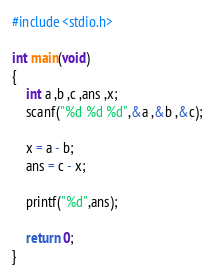<code> <loc_0><loc_0><loc_500><loc_500><_C_>#include <stdio.h>

int main(void)
{
	int a ,b ,c ,ans ,x;
	scanf("%d %d %d",&a ,&b ,&c);
	
	x = a - b;
	ans = c - x;
	
	printf("%d",ans);
	
	return 0;
}</code> 